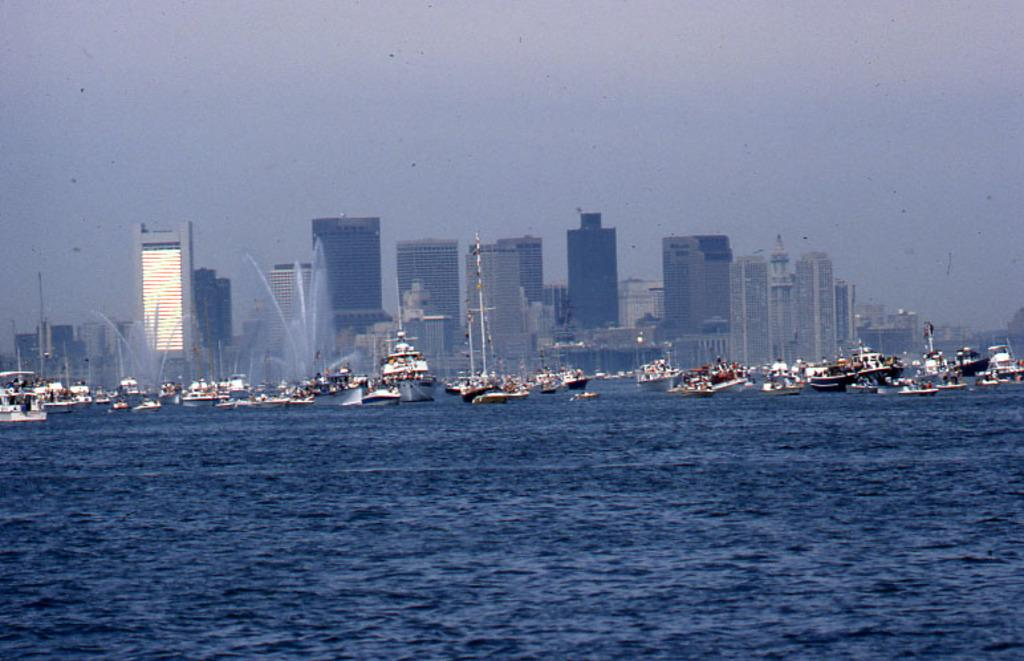What is positioned above the water in the image? There are boats above the water in the image. What can be seen in the background of the image? There are buildings in the background of the image. What type of stem can be seen growing near the boats in the image? There is no stem present in the image; it features boats above the water and buildings in the background. What time of day is depicted in the image? The time of day cannot be determined from the image, as there are no specific indicators of time. 